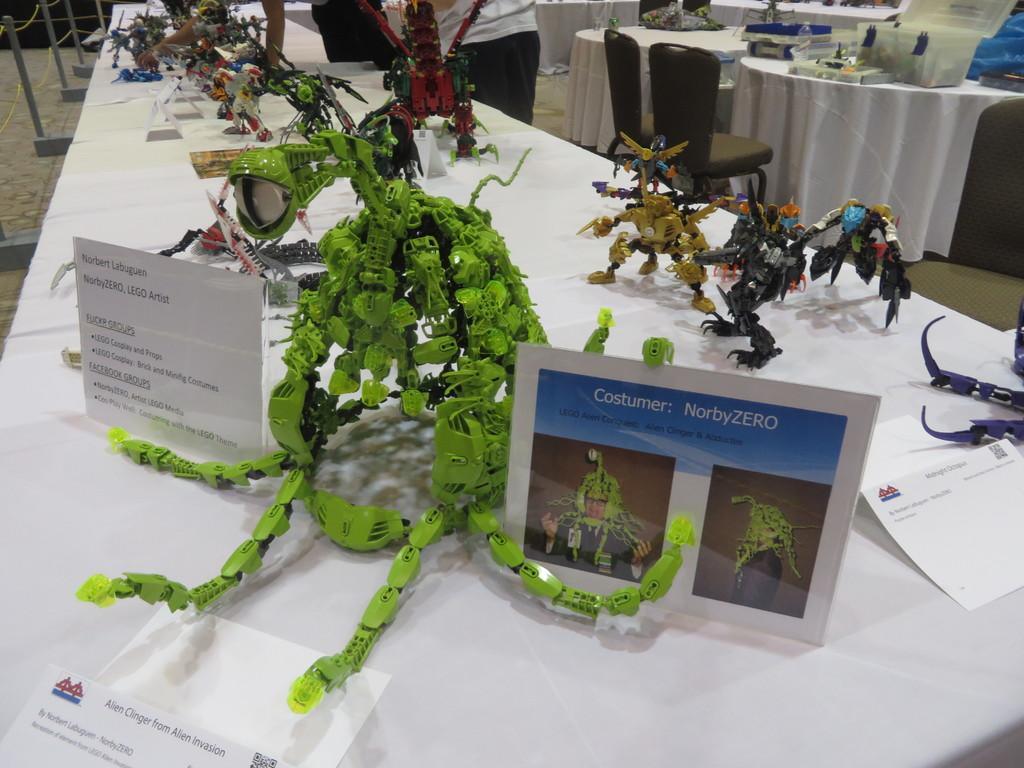Describe this image in one or two sentences. In this image we can see a person is standing at the top most center of the image. There are some objects placed on the table. 